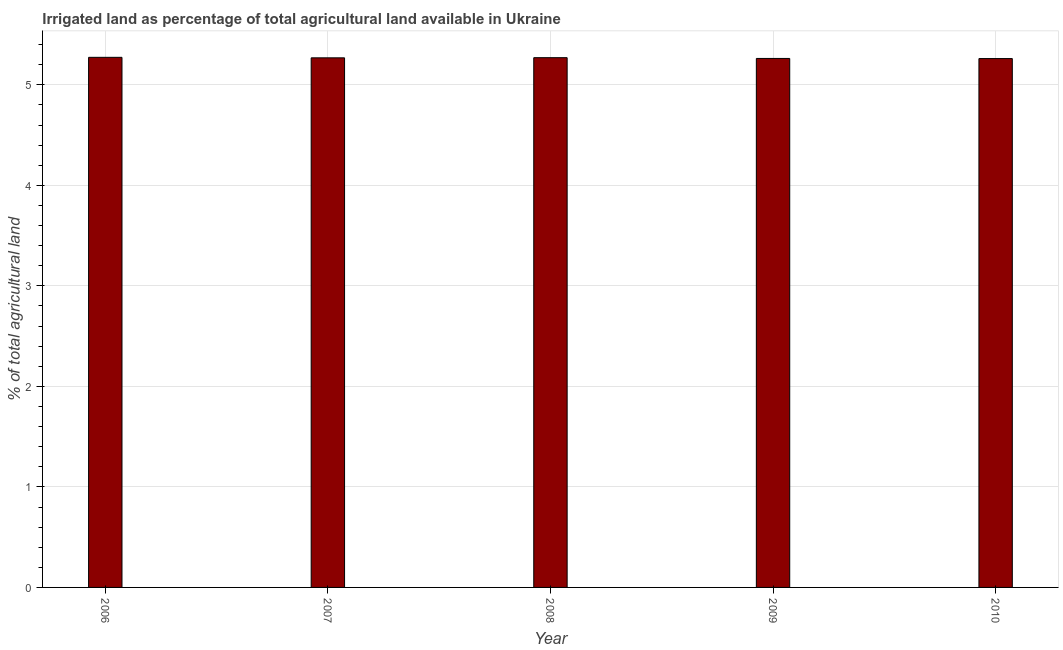Does the graph contain any zero values?
Your answer should be very brief. No. Does the graph contain grids?
Make the answer very short. Yes. What is the title of the graph?
Ensure brevity in your answer.  Irrigated land as percentage of total agricultural land available in Ukraine. What is the label or title of the X-axis?
Ensure brevity in your answer.  Year. What is the label or title of the Y-axis?
Your response must be concise. % of total agricultural land. What is the percentage of agricultural irrigated land in 2007?
Offer a terse response. 5.27. Across all years, what is the maximum percentage of agricultural irrigated land?
Offer a very short reply. 5.27. Across all years, what is the minimum percentage of agricultural irrigated land?
Give a very brief answer. 5.26. In which year was the percentage of agricultural irrigated land maximum?
Offer a terse response. 2006. What is the sum of the percentage of agricultural irrigated land?
Keep it short and to the point. 26.33. What is the difference between the percentage of agricultural irrigated land in 2007 and 2009?
Make the answer very short. 0.01. What is the average percentage of agricultural irrigated land per year?
Your answer should be very brief. 5.27. What is the median percentage of agricultural irrigated land?
Make the answer very short. 5.27. In how many years, is the percentage of agricultural irrigated land greater than 0.6 %?
Ensure brevity in your answer.  5. What is the ratio of the percentage of agricultural irrigated land in 2008 to that in 2010?
Ensure brevity in your answer.  1. Is the percentage of agricultural irrigated land in 2007 less than that in 2010?
Make the answer very short. No. Is the difference between the percentage of agricultural irrigated land in 2007 and 2010 greater than the difference between any two years?
Provide a succinct answer. No. What is the difference between the highest and the second highest percentage of agricultural irrigated land?
Your response must be concise. 0. Is the sum of the percentage of agricultural irrigated land in 2006 and 2007 greater than the maximum percentage of agricultural irrigated land across all years?
Provide a succinct answer. Yes. In how many years, is the percentage of agricultural irrigated land greater than the average percentage of agricultural irrigated land taken over all years?
Offer a terse response. 3. Are all the bars in the graph horizontal?
Offer a very short reply. No. What is the difference between two consecutive major ticks on the Y-axis?
Offer a very short reply. 1. What is the % of total agricultural land of 2006?
Make the answer very short. 5.27. What is the % of total agricultural land of 2007?
Ensure brevity in your answer.  5.27. What is the % of total agricultural land of 2008?
Your answer should be compact. 5.27. What is the % of total agricultural land of 2009?
Ensure brevity in your answer.  5.26. What is the % of total agricultural land of 2010?
Offer a very short reply. 5.26. What is the difference between the % of total agricultural land in 2006 and 2007?
Your answer should be compact. 0. What is the difference between the % of total agricultural land in 2006 and 2008?
Your response must be concise. 0. What is the difference between the % of total agricultural land in 2006 and 2009?
Your answer should be compact. 0.01. What is the difference between the % of total agricultural land in 2006 and 2010?
Offer a very short reply. 0.01. What is the difference between the % of total agricultural land in 2007 and 2008?
Your response must be concise. -0. What is the difference between the % of total agricultural land in 2007 and 2009?
Offer a very short reply. 0.01. What is the difference between the % of total agricultural land in 2007 and 2010?
Make the answer very short. 0.01. What is the difference between the % of total agricultural land in 2008 and 2009?
Provide a short and direct response. 0.01. What is the difference between the % of total agricultural land in 2008 and 2010?
Provide a short and direct response. 0.01. What is the difference between the % of total agricultural land in 2009 and 2010?
Provide a succinct answer. 0. What is the ratio of the % of total agricultural land in 2006 to that in 2008?
Your response must be concise. 1. What is the ratio of the % of total agricultural land in 2006 to that in 2009?
Your response must be concise. 1. What is the ratio of the % of total agricultural land in 2006 to that in 2010?
Make the answer very short. 1. 